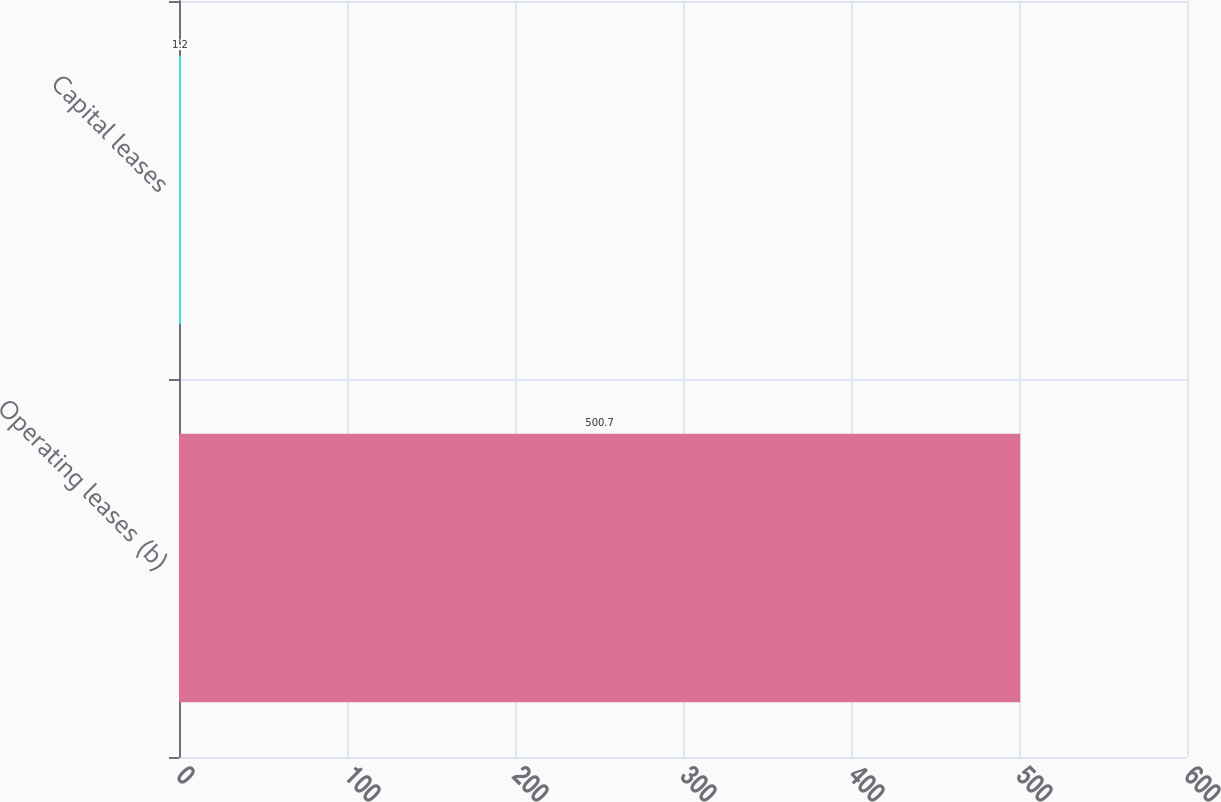Convert chart to OTSL. <chart><loc_0><loc_0><loc_500><loc_500><bar_chart><fcel>Operating leases (b)<fcel>Capital leases<nl><fcel>500.7<fcel>1.2<nl></chart> 